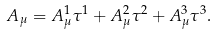Convert formula to latex. <formula><loc_0><loc_0><loc_500><loc_500>A _ { \mu } = A _ { \mu } ^ { 1 } \tau ^ { 1 } + A _ { \mu } ^ { 2 } \tau ^ { 2 } + A _ { \mu } ^ { 3 } \tau ^ { 3 } .</formula> 